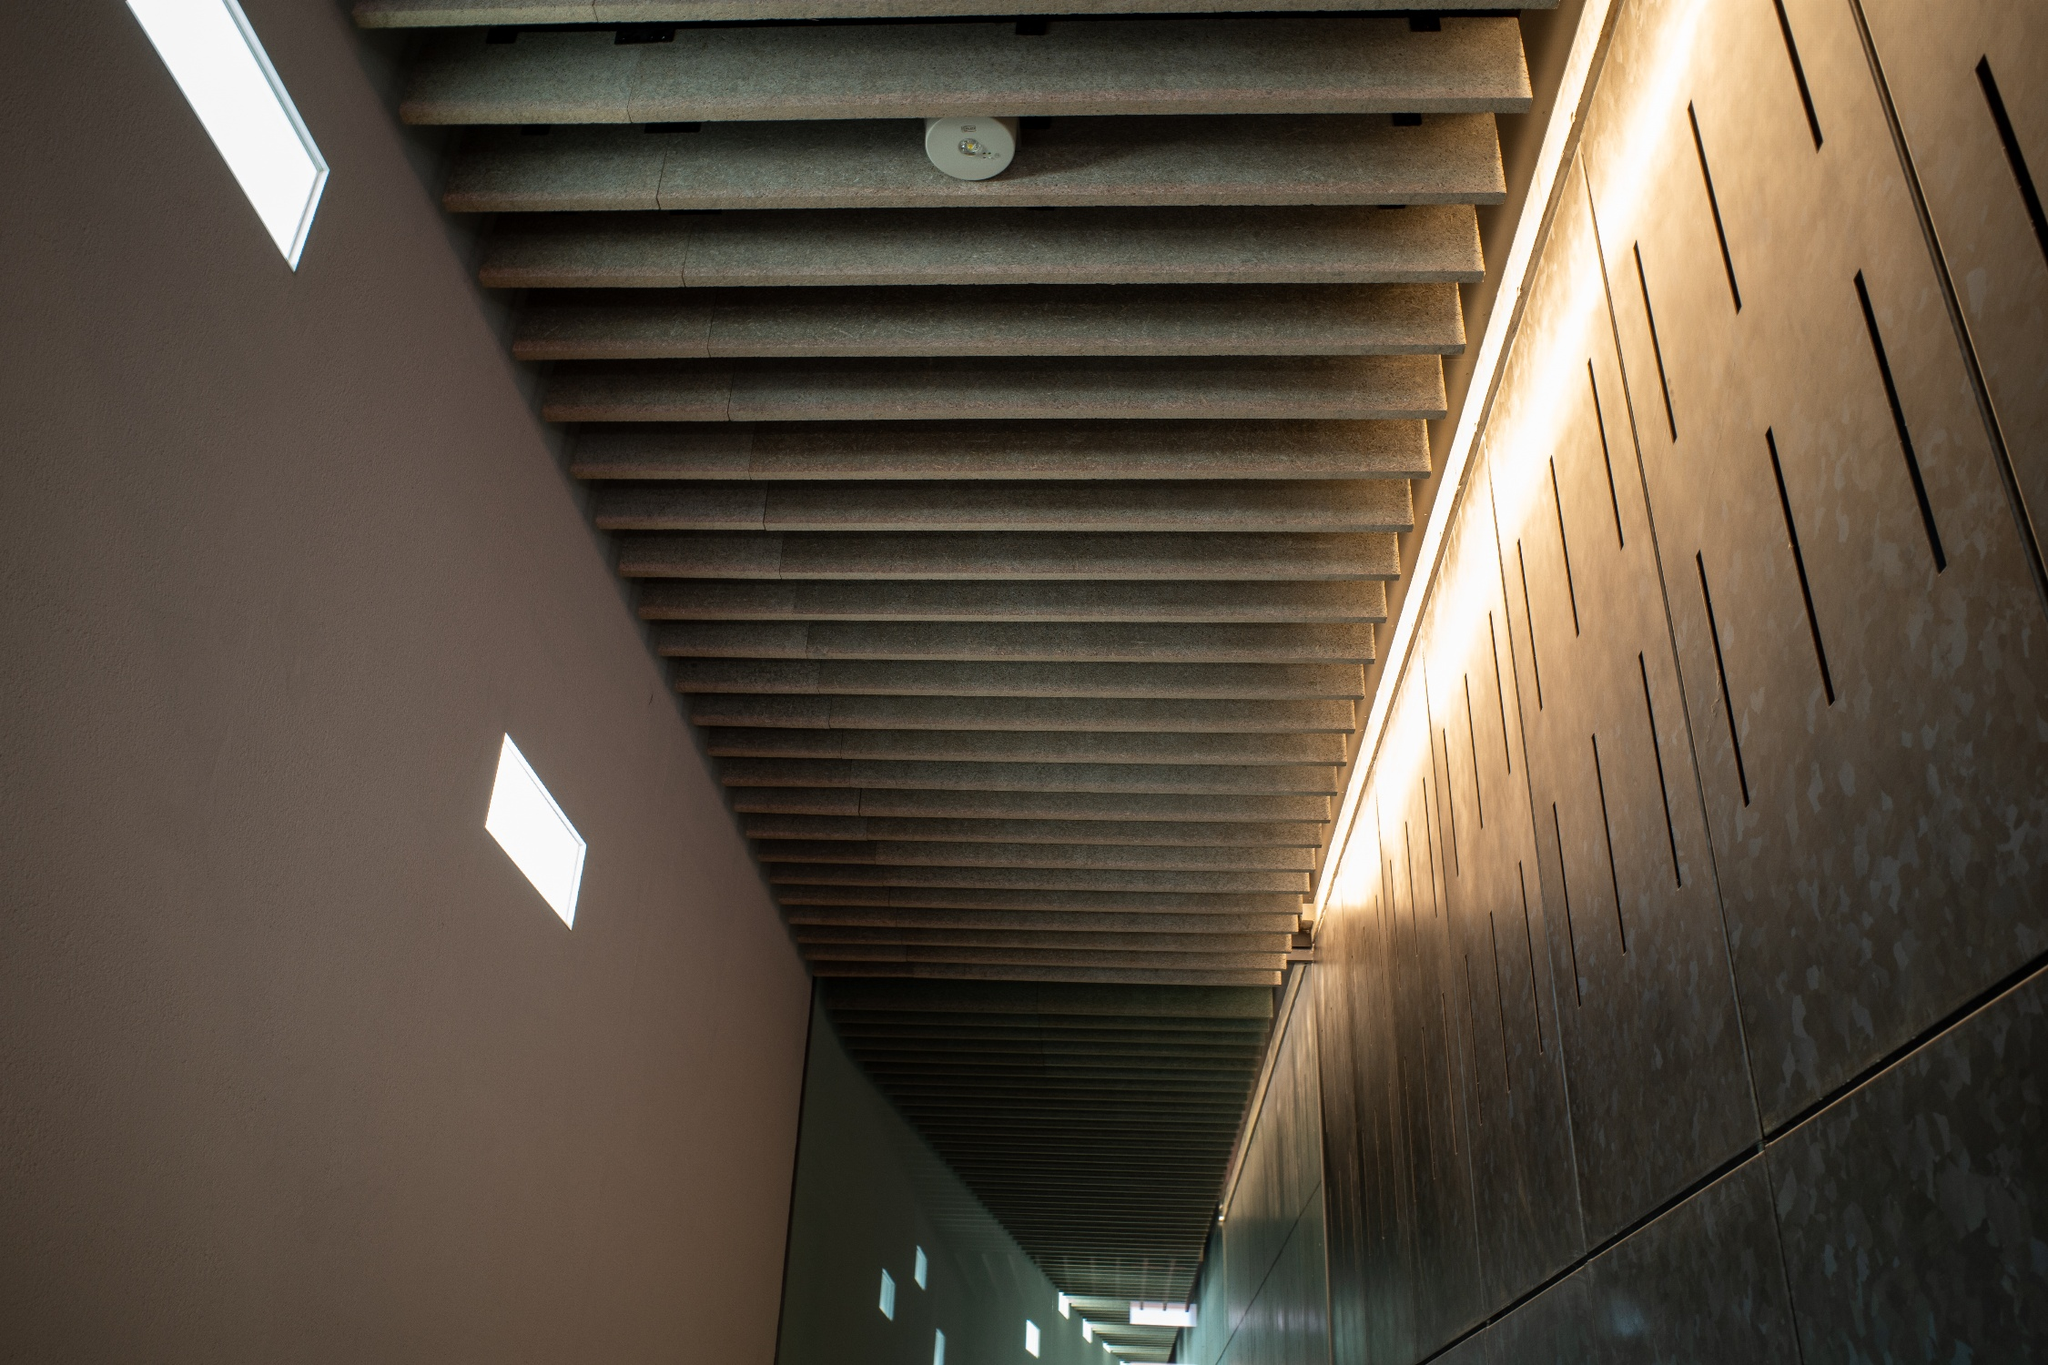Describe a realistic scenario of the image in a corporate environment (long response). In a leading corporate headquarters, this hallway serves as the main thoroughfare connecting executive offices with conference rooms and collaborative workspaces. The ribbed, brown ceiling, combined with recessed lighting, creates a professional yet comfortable atmosphere, promoting focused and creative thinking. Employees and visitors pass through this space, often pausing to appreciate the minimalist aesthetic that subtly reinforces the company's brand of innovation and sophistication. The small rectangular windows strategically allow just enough natural light to keep the corridor well-lit without distraction. Polished stone floors mirror the streamlined design ethos, embodying both efficiency and elegance. Alongside the walls, digital displays intermittently showcase the company’s latest achievements and upcoming projects, melding form with function seamlessly. This hallway is more than just a passage; it’s a statement of the company’s commitment to forward-thinking design and a productive work environment. 